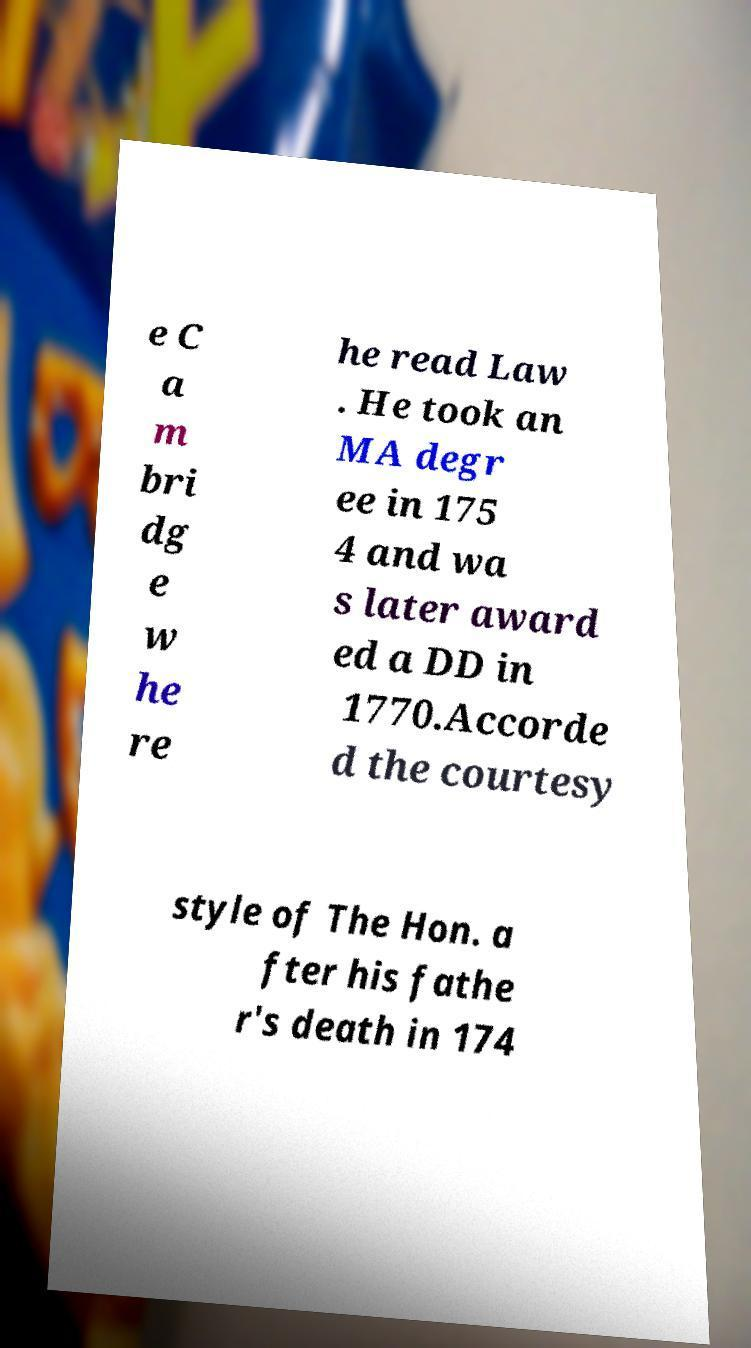Can you accurately transcribe the text from the provided image for me? e C a m bri dg e w he re he read Law . He took an MA degr ee in 175 4 and wa s later award ed a DD in 1770.Accorde d the courtesy style of The Hon. a fter his fathe r's death in 174 